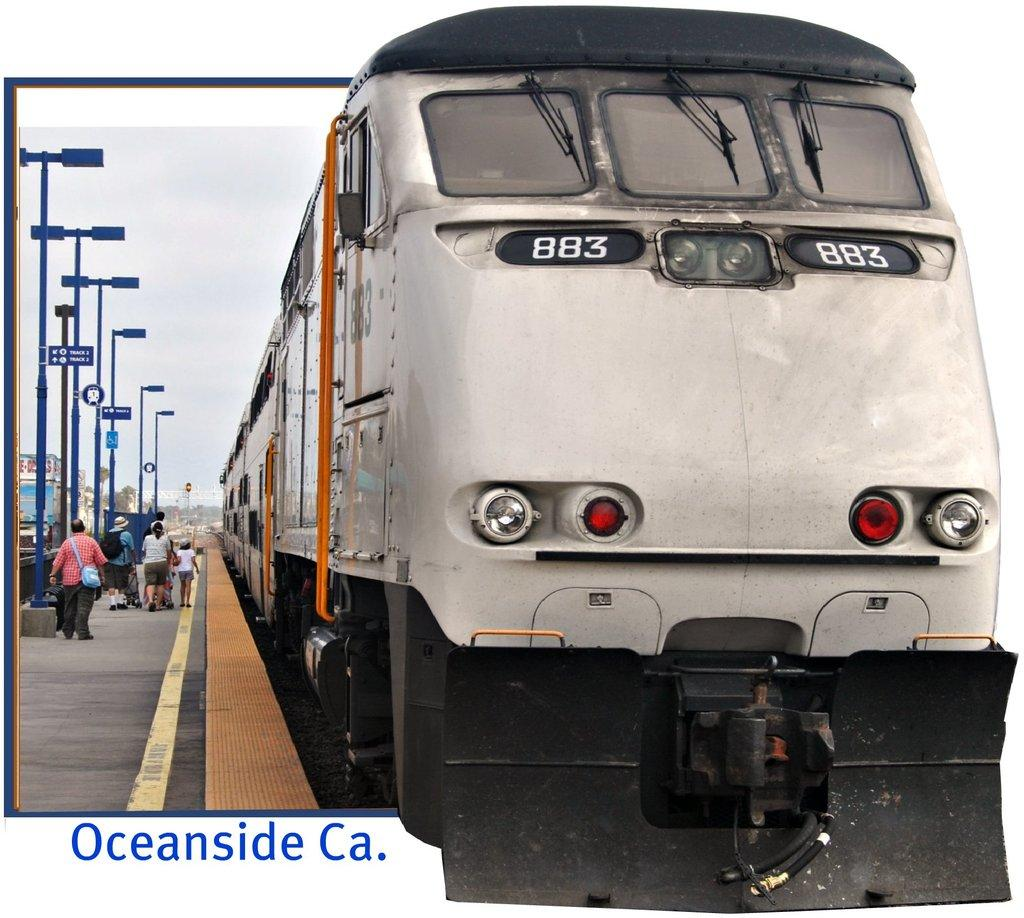<image>
Write a terse but informative summary of the picture. a bus with the number 883 on the front of it 